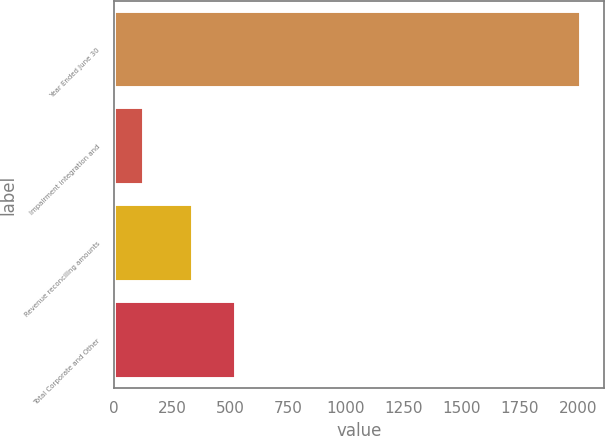Convert chart. <chart><loc_0><loc_0><loc_500><loc_500><bar_chart><fcel>Year Ended June 30<fcel>Impairment integration and<fcel>Revenue reconciling amounts<fcel>Total Corporate and Other<nl><fcel>2014<fcel>127<fcel>338<fcel>526.7<nl></chart> 